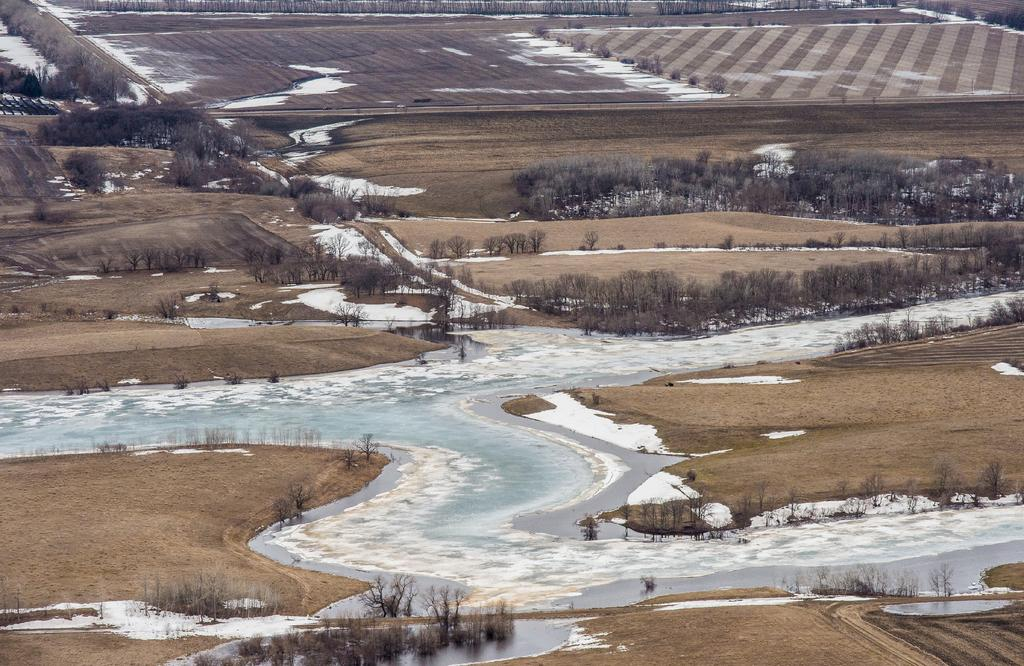What type of vegetation can be seen in the image? There are trees and plants in the image. What is the condition of the ground in the image? There appears to be water on the ground in the image. What is the weather like in the image? The presence of snow suggests that it is cold or wintry in the image. What is in the pocket of the tree in the image? There are no pockets present on the trees in the image, as trees are not human-like objects with pockets. 